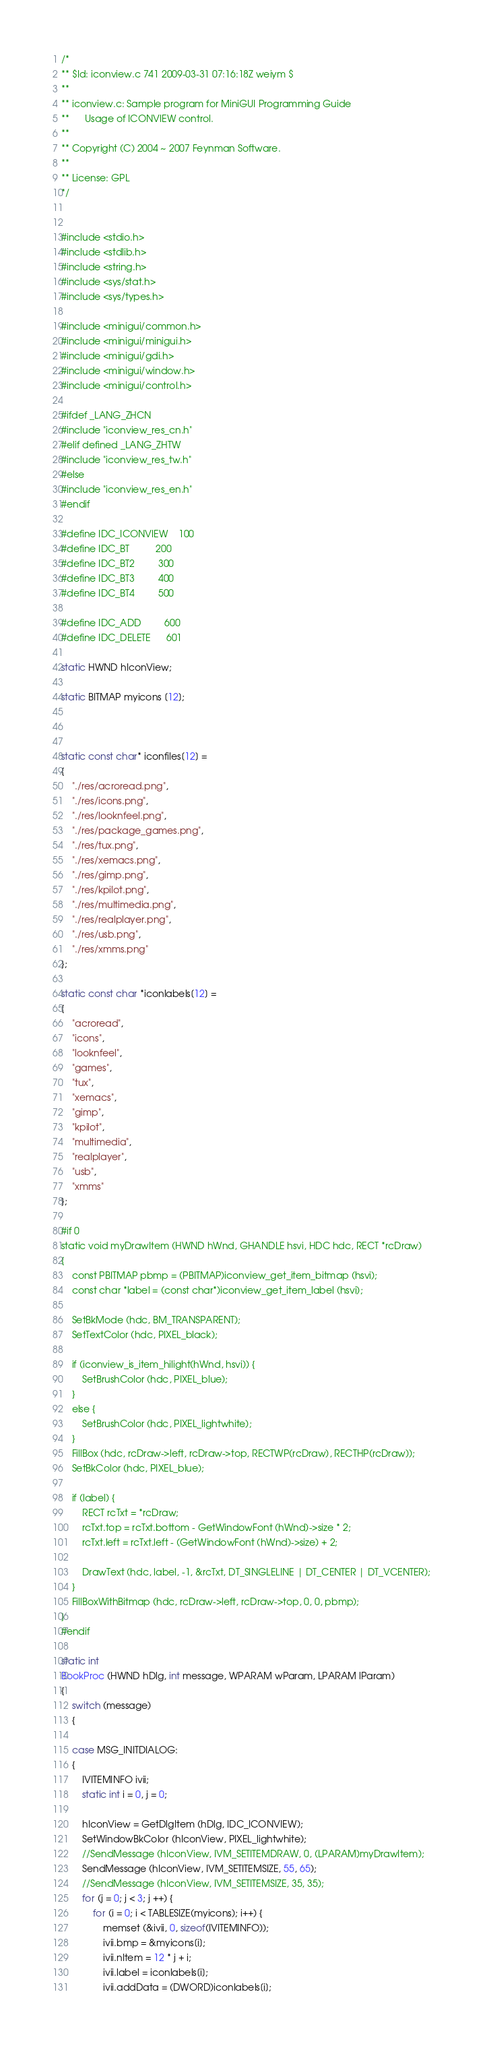Convert code to text. <code><loc_0><loc_0><loc_500><loc_500><_C_>/*
** $Id: iconview.c 741 2009-03-31 07:16:18Z weiym $
**
** iconview.c: Sample program for MiniGUI Programming Guide
**      Usage of ICONVIEW control.
**
** Copyright (C) 2004 ~ 2007 Feynman Software.
**
** License: GPL
*/


#include <stdio.h>
#include <stdlib.h>
#include <string.h>
#include <sys/stat.h>
#include <sys/types.h>

#include <minigui/common.h>
#include <minigui/minigui.h>
#include <minigui/gdi.h>
#include <minigui/window.h>
#include <minigui/control.h>

#ifdef _LANG_ZHCN
#include "iconview_res_cn.h"
#elif defined _LANG_ZHTW
#include "iconview_res_tw.h"
#else
#include "iconview_res_en.h"
#endif

#define IDC_ICONVIEW    100
#define IDC_BT          200
#define IDC_BT2         300
#define IDC_BT3         400
#define IDC_BT4         500

#define IDC_ADD         600
#define IDC_DELETE      601

static HWND hIconView;

static BITMAP myicons [12];



static const char* iconfiles[12] =
{
    "./res/acroread.png",
    "./res/icons.png",
    "./res/looknfeel.png",
    "./res/package_games.png",
    "./res/tux.png",
    "./res/xemacs.png",
    "./res/gimp.png",
    "./res/kpilot.png",
    "./res/multimedia.png",
    "./res/realplayer.png",
    "./res/usb.png",
    "./res/xmms.png"
};

static const char *iconlabels[12] =
{
    "acroread",
    "icons",
    "looknfeel",
    "games",
    "tux",
    "xemacs",
    "gimp",
    "kpilot",
    "multimedia",
    "realplayer",
    "usb",
    "xmms"
};

#if 0
static void myDrawItem (HWND hWnd, GHANDLE hsvi, HDC hdc, RECT *rcDraw)
{
    const PBITMAP pbmp = (PBITMAP)iconview_get_item_bitmap (hsvi);
    const char *label = (const char*)iconview_get_item_label (hsvi);
    
    SetBkMode (hdc, BM_TRANSPARENT);
    SetTextColor (hdc, PIXEL_black);

    if (iconview_is_item_hilight(hWnd, hsvi)) {
        SetBrushColor (hdc, PIXEL_blue);
    }
    else {
        SetBrushColor (hdc, PIXEL_lightwhite);
    }
    FillBox (hdc, rcDraw->left, rcDraw->top, RECTWP(rcDraw), RECTHP(rcDraw));
    SetBkColor (hdc, PIXEL_blue);
    
    if (label) {
        RECT rcTxt = *rcDraw;
        rcTxt.top = rcTxt.bottom - GetWindowFont (hWnd)->size * 2;
        rcTxt.left = rcTxt.left - (GetWindowFont (hWnd)->size) + 2;

        DrawText (hdc, label, -1, &rcTxt, DT_SINGLELINE | DT_CENTER | DT_VCENTER);
    }
    FillBoxWithBitmap (hdc, rcDraw->left, rcDraw->top, 0, 0, pbmp);
}
#endif

static int
BookProc (HWND hDlg, int message, WPARAM wParam, LPARAM lParam)
{
    switch (message)
    {
    
    case MSG_INITDIALOG:
    {
        IVITEMINFO ivii;
        static int i = 0, j = 0;

        hIconView = GetDlgItem (hDlg, IDC_ICONVIEW);
        SetWindowBkColor (hIconView, PIXEL_lightwhite);
        //SendMessage (hIconView, IVM_SETITEMDRAW, 0, (LPARAM)myDrawItem);
        SendMessage (hIconView, IVM_SETITEMSIZE, 55, 65);
        //SendMessage (hIconView, IVM_SETITEMSIZE, 35, 35);
        for (j = 0; j < 3; j ++) {
            for (i = 0; i < TABLESIZE(myicons); i++) {
                memset (&ivii, 0, sizeof(IVITEMINFO));
                ivii.bmp = &myicons[i];
                ivii.nItem = 12 * j + i;
                ivii.label = iconlabels[i];
                ivii.addData = (DWORD)iconlabels[i];</code> 